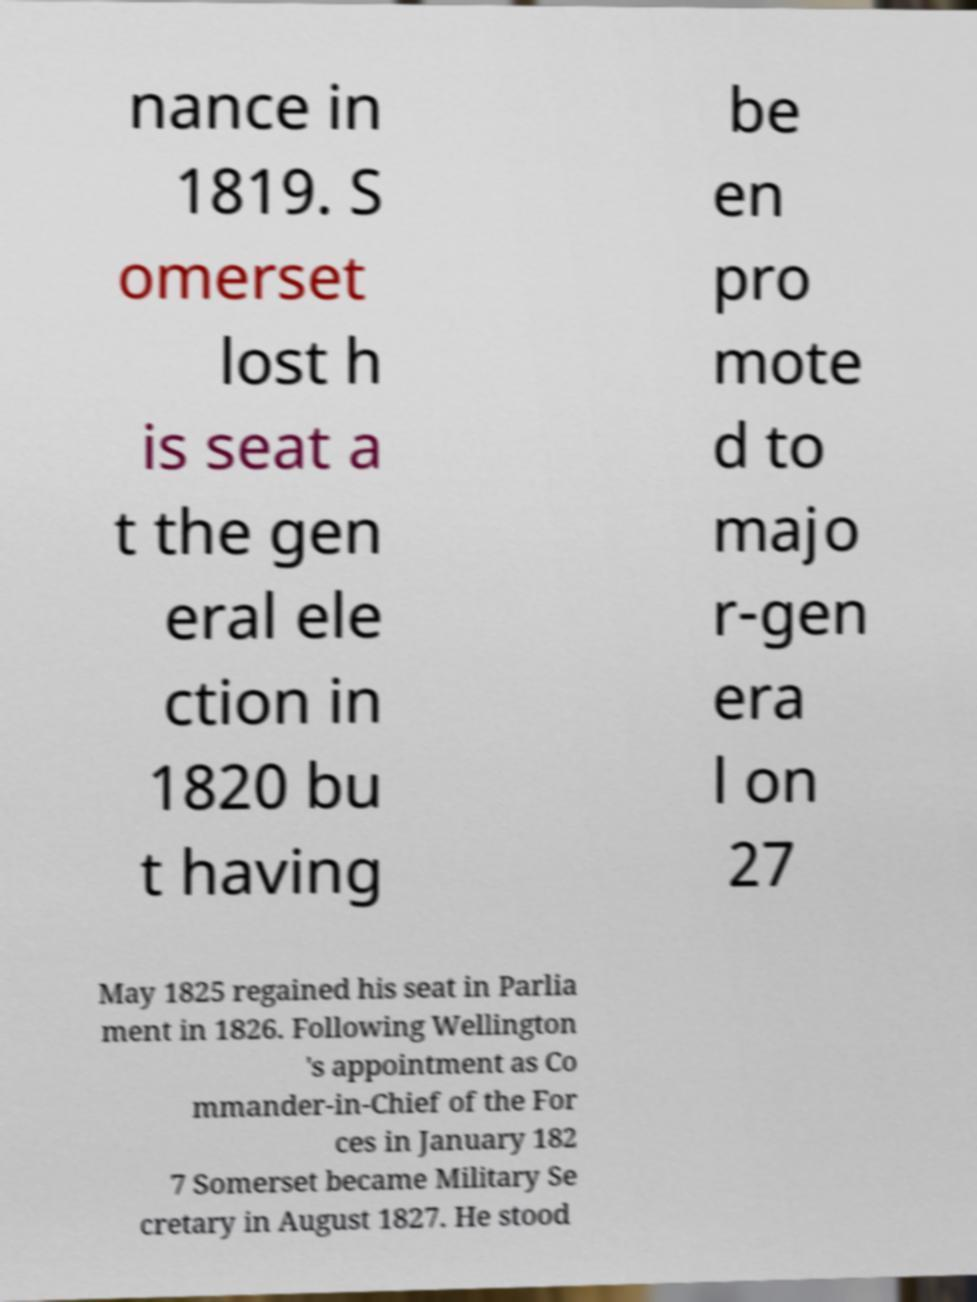What messages or text are displayed in this image? I need them in a readable, typed format. nance in 1819. S omerset lost h is seat a t the gen eral ele ction in 1820 bu t having be en pro mote d to majo r-gen era l on 27 May 1825 regained his seat in Parlia ment in 1826. Following Wellington 's appointment as Co mmander-in-Chief of the For ces in January 182 7 Somerset became Military Se cretary in August 1827. He stood 